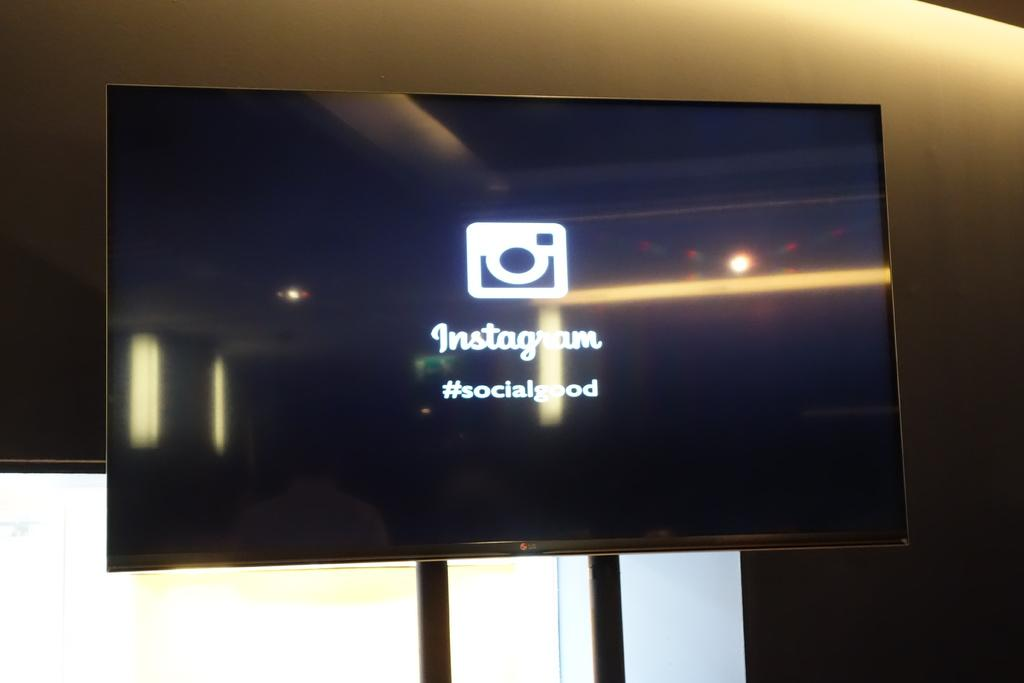<image>
Provide a brief description of the given image. a monitor with Instagram logo and #socialgood on it 